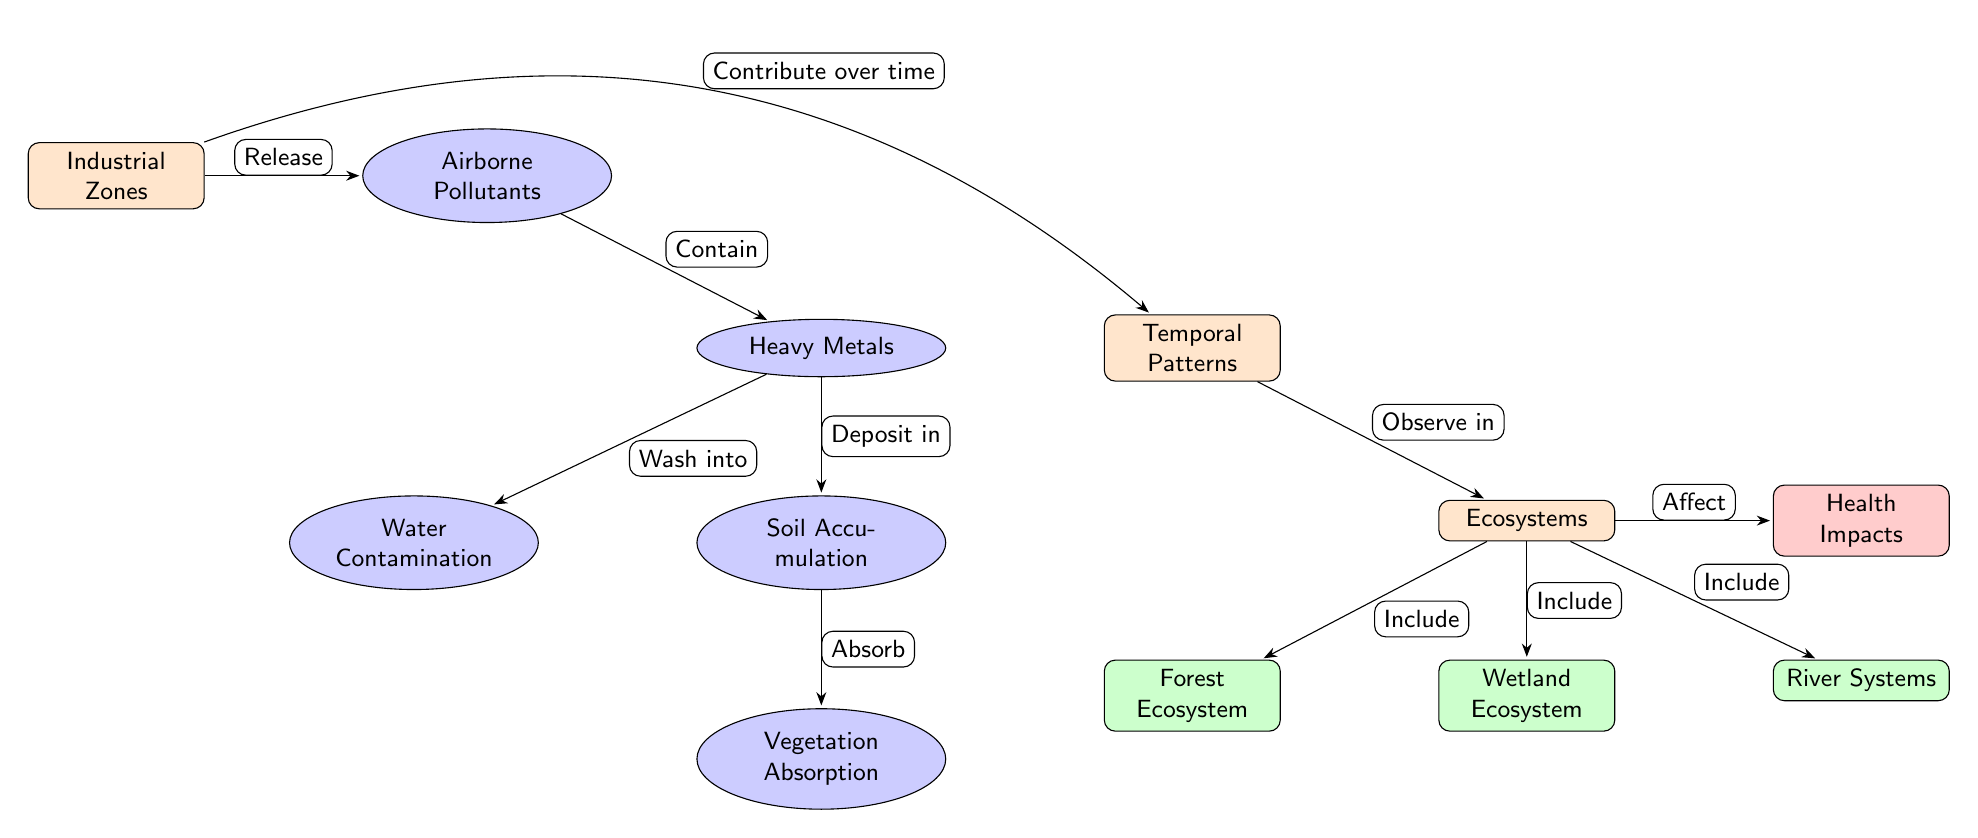What is the first process listed in the diagram? The diagram starts with the node labeled "Industrial Zones," which is the main source leading to airborne pollutants, indicating the first step in the process.
Answer: Industrial Zones How many ecosystems are included in the diagram? The diagram lists three ecosystems: Forest Ecosystem, Wetland Ecosystem, and River Systems. Counting these, we find a total of three ecosystems depicted.
Answer: 3 What do airborne pollutants release, according to the diagram? According to the diagram, the "Industrial Zones" releases "Airborne Pollutants," which is the next step in the sequence following the initial node.
Answer: Airborne Pollutants What process results from soil accumulation of heavy metals? The diagram indicates that "Soil Accumulation" leads to "Vegetation Absorption," meaning this process signifies how heavy metals are taken up by plant life.
Answer: Vegetation Absorption Which ecosystem is directly linked to health impacts? The diagram illustrates that all three ecosystems (Forest, Wetland, River) affect health impacts as indicated by the edge labeled "Affect" leading from the ecosystem node to the health impacts node.
Answer: Ecosystems What relationship does "Temporal Patterns" have with "Industrial Zones"? The connection shows that "Industrial Zones" contribute over time to the "Temporal Patterns," implying a progression or change over time in the context of heavy metal accumulation.
Answer: Contribute over time What is deposited in the soil from heavy metals? The diagram explicitly shows that heavy metals are deposited in the "Soil Accumulation," indicating their movement from one phase to another within the ecosystem.
Answer: Soil Accumulation Which impact is most relevant according to the ecosystem node? The diagram indicates that health impacts are directly linked to the ecosystems, suggesting the toxicological relevance of metal accumulation in terms of human and ecological health.
Answer: Health Impacts What is the consequence of airborne pollutants according to the diagram? The diagram illustrates that airborne pollutants contain heavy metals, indicating their direct influence on air quality and subsequent environmental impacts.
Answer: Heavy Metals 